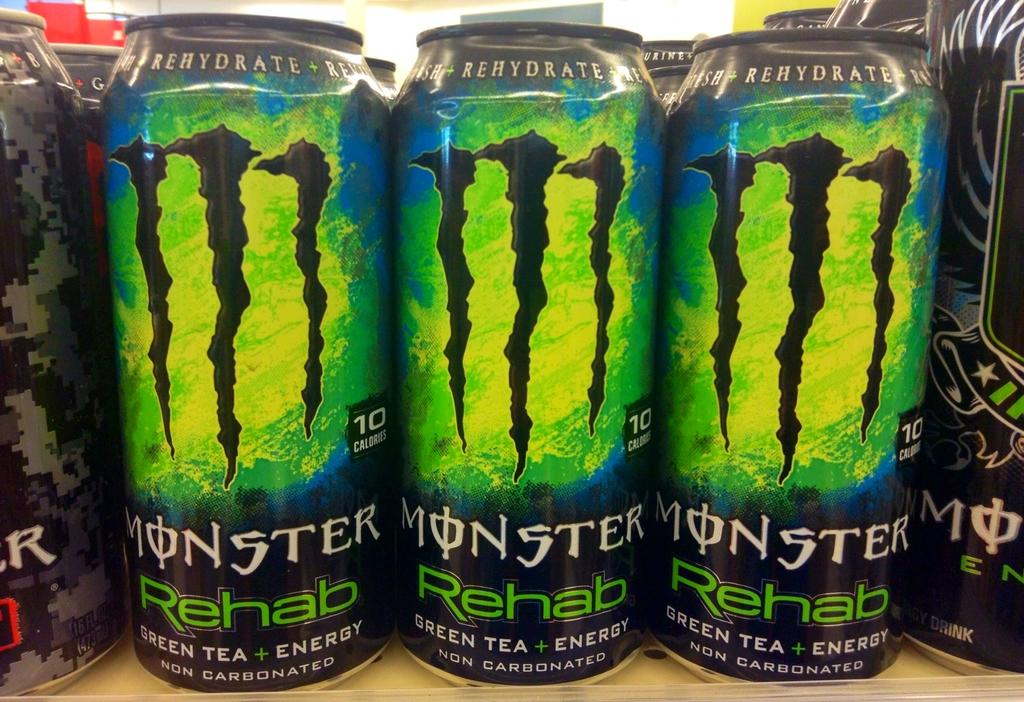Provide a one-sentence caption for the provided image. Cans of Monster energy drinks line a shelf. 